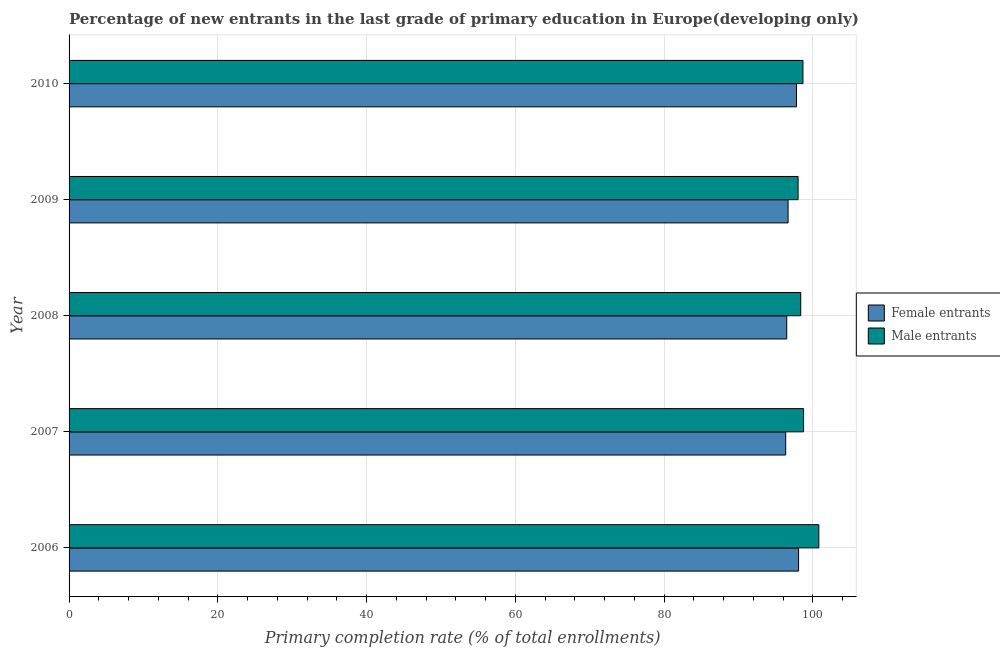How many groups of bars are there?
Give a very brief answer. 5. How many bars are there on the 5th tick from the bottom?
Your answer should be very brief. 2. In how many cases, is the number of bars for a given year not equal to the number of legend labels?
Ensure brevity in your answer.  0. What is the primary completion rate of female entrants in 2010?
Provide a succinct answer. 97.79. Across all years, what is the maximum primary completion rate of male entrants?
Give a very brief answer. 100.79. Across all years, what is the minimum primary completion rate of female entrants?
Make the answer very short. 96.34. In which year was the primary completion rate of male entrants maximum?
Your answer should be very brief. 2006. What is the total primary completion rate of male entrants in the graph?
Your response must be concise. 494.55. What is the difference between the primary completion rate of male entrants in 2006 and that in 2009?
Offer a very short reply. 2.79. What is the difference between the primary completion rate of male entrants in 2010 and the primary completion rate of female entrants in 2009?
Provide a short and direct response. 2. What is the average primary completion rate of female entrants per year?
Ensure brevity in your answer.  97.07. In the year 2008, what is the difference between the primary completion rate of male entrants and primary completion rate of female entrants?
Your response must be concise. 1.88. In how many years, is the primary completion rate of female entrants greater than 40 %?
Your response must be concise. 5. What is the ratio of the primary completion rate of male entrants in 2009 to that in 2010?
Offer a very short reply. 0.99. Is the primary completion rate of female entrants in 2007 less than that in 2010?
Provide a succinct answer. Yes. What is the difference between the highest and the second highest primary completion rate of male entrants?
Your response must be concise. 2.05. What is the difference between the highest and the lowest primary completion rate of female entrants?
Provide a succinct answer. 1.73. Is the sum of the primary completion rate of female entrants in 2007 and 2010 greater than the maximum primary completion rate of male entrants across all years?
Provide a short and direct response. Yes. What does the 2nd bar from the top in 2010 represents?
Provide a short and direct response. Female entrants. What does the 2nd bar from the bottom in 2006 represents?
Keep it short and to the point. Male entrants. How many bars are there?
Keep it short and to the point. 10. Are all the bars in the graph horizontal?
Offer a terse response. Yes. How many years are there in the graph?
Offer a terse response. 5. Are the values on the major ticks of X-axis written in scientific E-notation?
Provide a succinct answer. No. Does the graph contain any zero values?
Provide a succinct answer. No. Does the graph contain grids?
Keep it short and to the point. Yes. Where does the legend appear in the graph?
Provide a succinct answer. Center right. How many legend labels are there?
Provide a succinct answer. 2. What is the title of the graph?
Provide a succinct answer. Percentage of new entrants in the last grade of primary education in Europe(developing only). Does "Lowest 20% of population" appear as one of the legend labels in the graph?
Your response must be concise. No. What is the label or title of the X-axis?
Your answer should be compact. Primary completion rate (% of total enrollments). What is the label or title of the Y-axis?
Make the answer very short. Year. What is the Primary completion rate (% of total enrollments) of Female entrants in 2006?
Your answer should be compact. 98.07. What is the Primary completion rate (% of total enrollments) of Male entrants in 2006?
Provide a short and direct response. 100.79. What is the Primary completion rate (% of total enrollments) of Female entrants in 2007?
Make the answer very short. 96.34. What is the Primary completion rate (% of total enrollments) of Male entrants in 2007?
Offer a very short reply. 98.74. What is the Primary completion rate (% of total enrollments) in Female entrants in 2008?
Ensure brevity in your answer.  96.48. What is the Primary completion rate (% of total enrollments) in Male entrants in 2008?
Provide a short and direct response. 98.36. What is the Primary completion rate (% of total enrollments) in Female entrants in 2009?
Provide a short and direct response. 96.66. What is the Primary completion rate (% of total enrollments) of Male entrants in 2009?
Your answer should be very brief. 98. What is the Primary completion rate (% of total enrollments) in Female entrants in 2010?
Your response must be concise. 97.79. What is the Primary completion rate (% of total enrollments) in Male entrants in 2010?
Provide a short and direct response. 98.66. Across all years, what is the maximum Primary completion rate (% of total enrollments) of Female entrants?
Ensure brevity in your answer.  98.07. Across all years, what is the maximum Primary completion rate (% of total enrollments) in Male entrants?
Your answer should be compact. 100.79. Across all years, what is the minimum Primary completion rate (% of total enrollments) of Female entrants?
Provide a succinct answer. 96.34. Across all years, what is the minimum Primary completion rate (% of total enrollments) in Male entrants?
Provide a succinct answer. 98. What is the total Primary completion rate (% of total enrollments) of Female entrants in the graph?
Offer a terse response. 485.34. What is the total Primary completion rate (% of total enrollments) in Male entrants in the graph?
Offer a terse response. 494.55. What is the difference between the Primary completion rate (% of total enrollments) of Female entrants in 2006 and that in 2007?
Your answer should be very brief. 1.73. What is the difference between the Primary completion rate (% of total enrollments) in Male entrants in 2006 and that in 2007?
Give a very brief answer. 2.05. What is the difference between the Primary completion rate (% of total enrollments) of Female entrants in 2006 and that in 2008?
Make the answer very short. 1.59. What is the difference between the Primary completion rate (% of total enrollments) of Male entrants in 2006 and that in 2008?
Your answer should be compact. 2.43. What is the difference between the Primary completion rate (% of total enrollments) of Female entrants in 2006 and that in 2009?
Offer a terse response. 1.41. What is the difference between the Primary completion rate (% of total enrollments) in Male entrants in 2006 and that in 2009?
Provide a short and direct response. 2.79. What is the difference between the Primary completion rate (% of total enrollments) in Female entrants in 2006 and that in 2010?
Provide a short and direct response. 0.28. What is the difference between the Primary completion rate (% of total enrollments) of Male entrants in 2006 and that in 2010?
Your response must be concise. 2.13. What is the difference between the Primary completion rate (% of total enrollments) in Female entrants in 2007 and that in 2008?
Give a very brief answer. -0.14. What is the difference between the Primary completion rate (% of total enrollments) of Male entrants in 2007 and that in 2008?
Provide a succinct answer. 0.38. What is the difference between the Primary completion rate (% of total enrollments) in Female entrants in 2007 and that in 2009?
Give a very brief answer. -0.32. What is the difference between the Primary completion rate (% of total enrollments) in Male entrants in 2007 and that in 2009?
Offer a terse response. 0.74. What is the difference between the Primary completion rate (% of total enrollments) in Female entrants in 2007 and that in 2010?
Your response must be concise. -1.46. What is the difference between the Primary completion rate (% of total enrollments) of Male entrants in 2007 and that in 2010?
Keep it short and to the point. 0.08. What is the difference between the Primary completion rate (% of total enrollments) in Female entrants in 2008 and that in 2009?
Your response must be concise. -0.18. What is the difference between the Primary completion rate (% of total enrollments) of Male entrants in 2008 and that in 2009?
Offer a terse response. 0.35. What is the difference between the Primary completion rate (% of total enrollments) of Female entrants in 2008 and that in 2010?
Give a very brief answer. -1.32. What is the difference between the Primary completion rate (% of total enrollments) in Male entrants in 2008 and that in 2010?
Offer a terse response. -0.3. What is the difference between the Primary completion rate (% of total enrollments) in Female entrants in 2009 and that in 2010?
Your answer should be very brief. -1.13. What is the difference between the Primary completion rate (% of total enrollments) in Male entrants in 2009 and that in 2010?
Give a very brief answer. -0.65. What is the difference between the Primary completion rate (% of total enrollments) in Female entrants in 2006 and the Primary completion rate (% of total enrollments) in Male entrants in 2007?
Make the answer very short. -0.67. What is the difference between the Primary completion rate (% of total enrollments) in Female entrants in 2006 and the Primary completion rate (% of total enrollments) in Male entrants in 2008?
Provide a succinct answer. -0.29. What is the difference between the Primary completion rate (% of total enrollments) of Female entrants in 2006 and the Primary completion rate (% of total enrollments) of Male entrants in 2009?
Your response must be concise. 0.07. What is the difference between the Primary completion rate (% of total enrollments) in Female entrants in 2006 and the Primary completion rate (% of total enrollments) in Male entrants in 2010?
Offer a very short reply. -0.59. What is the difference between the Primary completion rate (% of total enrollments) of Female entrants in 2007 and the Primary completion rate (% of total enrollments) of Male entrants in 2008?
Offer a very short reply. -2.02. What is the difference between the Primary completion rate (% of total enrollments) of Female entrants in 2007 and the Primary completion rate (% of total enrollments) of Male entrants in 2009?
Ensure brevity in your answer.  -1.67. What is the difference between the Primary completion rate (% of total enrollments) of Female entrants in 2007 and the Primary completion rate (% of total enrollments) of Male entrants in 2010?
Make the answer very short. -2.32. What is the difference between the Primary completion rate (% of total enrollments) in Female entrants in 2008 and the Primary completion rate (% of total enrollments) in Male entrants in 2009?
Provide a short and direct response. -1.53. What is the difference between the Primary completion rate (% of total enrollments) of Female entrants in 2008 and the Primary completion rate (% of total enrollments) of Male entrants in 2010?
Make the answer very short. -2.18. What is the difference between the Primary completion rate (% of total enrollments) of Female entrants in 2009 and the Primary completion rate (% of total enrollments) of Male entrants in 2010?
Ensure brevity in your answer.  -2. What is the average Primary completion rate (% of total enrollments) in Female entrants per year?
Your answer should be compact. 97.07. What is the average Primary completion rate (% of total enrollments) in Male entrants per year?
Your response must be concise. 98.91. In the year 2006, what is the difference between the Primary completion rate (% of total enrollments) of Female entrants and Primary completion rate (% of total enrollments) of Male entrants?
Give a very brief answer. -2.72. In the year 2007, what is the difference between the Primary completion rate (% of total enrollments) of Female entrants and Primary completion rate (% of total enrollments) of Male entrants?
Make the answer very short. -2.4. In the year 2008, what is the difference between the Primary completion rate (% of total enrollments) in Female entrants and Primary completion rate (% of total enrollments) in Male entrants?
Provide a succinct answer. -1.88. In the year 2009, what is the difference between the Primary completion rate (% of total enrollments) of Female entrants and Primary completion rate (% of total enrollments) of Male entrants?
Offer a very short reply. -1.35. In the year 2010, what is the difference between the Primary completion rate (% of total enrollments) in Female entrants and Primary completion rate (% of total enrollments) in Male entrants?
Give a very brief answer. -0.87. What is the ratio of the Primary completion rate (% of total enrollments) in Female entrants in 2006 to that in 2007?
Keep it short and to the point. 1.02. What is the ratio of the Primary completion rate (% of total enrollments) in Male entrants in 2006 to that in 2007?
Keep it short and to the point. 1.02. What is the ratio of the Primary completion rate (% of total enrollments) of Female entrants in 2006 to that in 2008?
Make the answer very short. 1.02. What is the ratio of the Primary completion rate (% of total enrollments) in Male entrants in 2006 to that in 2008?
Your answer should be compact. 1.02. What is the ratio of the Primary completion rate (% of total enrollments) of Female entrants in 2006 to that in 2009?
Ensure brevity in your answer.  1.01. What is the ratio of the Primary completion rate (% of total enrollments) in Male entrants in 2006 to that in 2009?
Your answer should be compact. 1.03. What is the ratio of the Primary completion rate (% of total enrollments) of Male entrants in 2006 to that in 2010?
Offer a very short reply. 1.02. What is the ratio of the Primary completion rate (% of total enrollments) of Female entrants in 2007 to that in 2009?
Your answer should be compact. 1. What is the ratio of the Primary completion rate (% of total enrollments) in Male entrants in 2007 to that in 2009?
Your answer should be very brief. 1.01. What is the ratio of the Primary completion rate (% of total enrollments) in Female entrants in 2007 to that in 2010?
Keep it short and to the point. 0.99. What is the ratio of the Primary completion rate (% of total enrollments) of Male entrants in 2007 to that in 2010?
Your answer should be compact. 1. What is the ratio of the Primary completion rate (% of total enrollments) in Male entrants in 2008 to that in 2009?
Keep it short and to the point. 1. What is the ratio of the Primary completion rate (% of total enrollments) in Female entrants in 2008 to that in 2010?
Offer a very short reply. 0.99. What is the ratio of the Primary completion rate (% of total enrollments) of Female entrants in 2009 to that in 2010?
Offer a very short reply. 0.99. What is the ratio of the Primary completion rate (% of total enrollments) of Male entrants in 2009 to that in 2010?
Give a very brief answer. 0.99. What is the difference between the highest and the second highest Primary completion rate (% of total enrollments) of Female entrants?
Provide a succinct answer. 0.28. What is the difference between the highest and the second highest Primary completion rate (% of total enrollments) in Male entrants?
Provide a succinct answer. 2.05. What is the difference between the highest and the lowest Primary completion rate (% of total enrollments) of Female entrants?
Make the answer very short. 1.73. What is the difference between the highest and the lowest Primary completion rate (% of total enrollments) in Male entrants?
Keep it short and to the point. 2.79. 